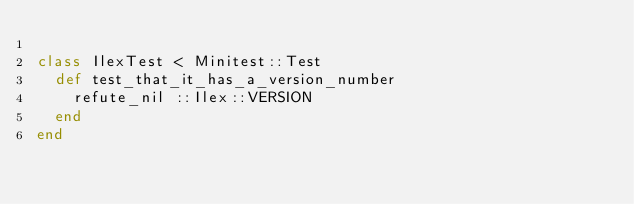<code> <loc_0><loc_0><loc_500><loc_500><_Ruby_>
class IlexTest < Minitest::Test
  def test_that_it_has_a_version_number
    refute_nil ::Ilex::VERSION
  end
end
</code> 